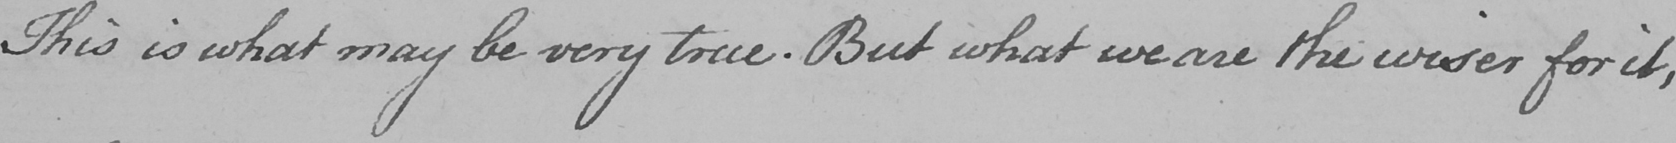Please provide the text content of this handwritten line. This is what may be very true . But what we are the wiser for it , 